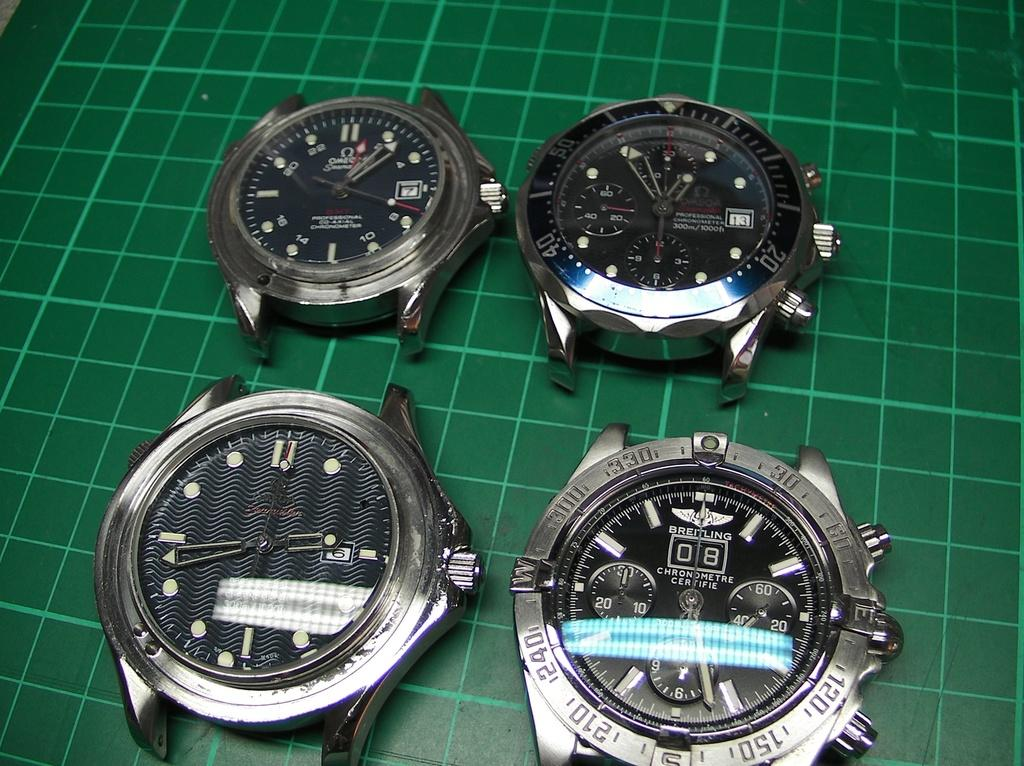<image>
Provide a brief description of the given image. four different watches one with the number 8 on it 